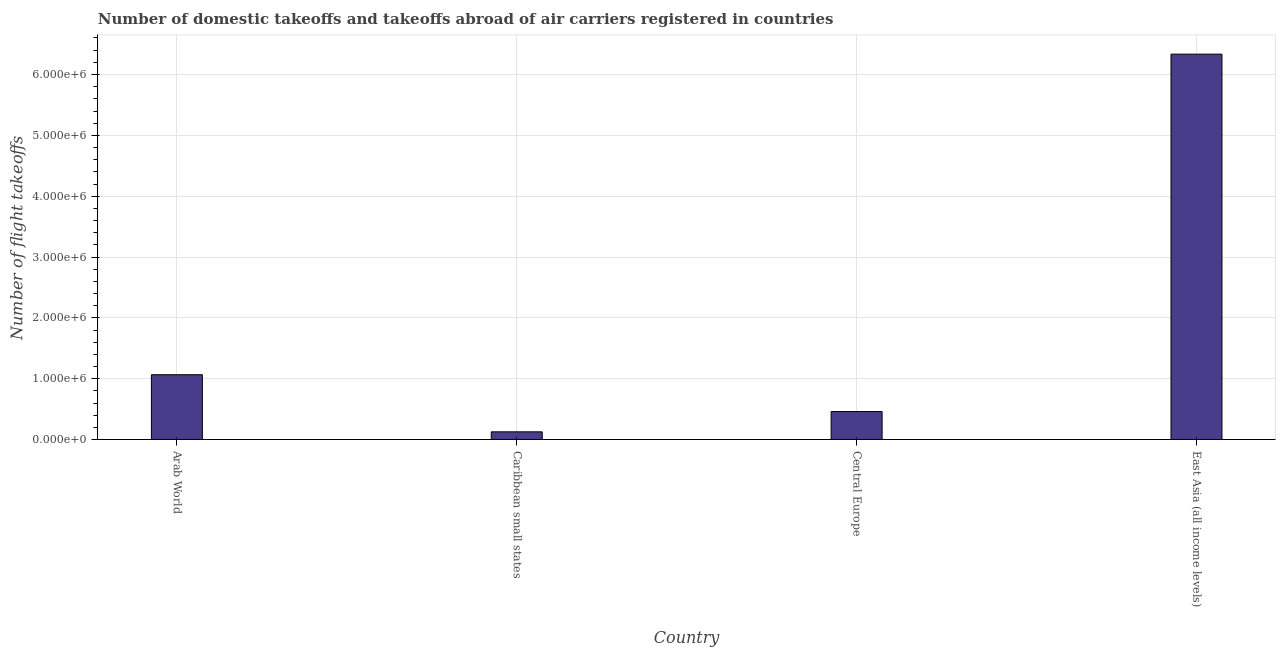What is the title of the graph?
Offer a very short reply. Number of domestic takeoffs and takeoffs abroad of air carriers registered in countries. What is the label or title of the X-axis?
Provide a short and direct response. Country. What is the label or title of the Y-axis?
Provide a succinct answer. Number of flight takeoffs. What is the number of flight takeoffs in Central Europe?
Offer a terse response. 4.60e+05. Across all countries, what is the maximum number of flight takeoffs?
Your response must be concise. 6.33e+06. Across all countries, what is the minimum number of flight takeoffs?
Your response must be concise. 1.26e+05. In which country was the number of flight takeoffs maximum?
Your answer should be very brief. East Asia (all income levels). In which country was the number of flight takeoffs minimum?
Your answer should be compact. Caribbean small states. What is the sum of the number of flight takeoffs?
Provide a succinct answer. 7.99e+06. What is the difference between the number of flight takeoffs in Caribbean small states and Central Europe?
Provide a short and direct response. -3.34e+05. What is the average number of flight takeoffs per country?
Offer a very short reply. 2.00e+06. What is the median number of flight takeoffs?
Offer a terse response. 7.63e+05. In how many countries, is the number of flight takeoffs greater than 5800000 ?
Your answer should be compact. 1. What is the ratio of the number of flight takeoffs in Arab World to that in East Asia (all income levels)?
Give a very brief answer. 0.17. What is the difference between the highest and the second highest number of flight takeoffs?
Make the answer very short. 5.27e+06. What is the difference between the highest and the lowest number of flight takeoffs?
Provide a short and direct response. 6.21e+06. In how many countries, is the number of flight takeoffs greater than the average number of flight takeoffs taken over all countries?
Offer a very short reply. 1. Are all the bars in the graph horizontal?
Your answer should be compact. No. What is the difference between two consecutive major ticks on the Y-axis?
Keep it short and to the point. 1.00e+06. Are the values on the major ticks of Y-axis written in scientific E-notation?
Your response must be concise. Yes. What is the Number of flight takeoffs in Arab World?
Your answer should be very brief. 1.07e+06. What is the Number of flight takeoffs in Caribbean small states?
Offer a terse response. 1.26e+05. What is the Number of flight takeoffs in Central Europe?
Offer a terse response. 4.60e+05. What is the Number of flight takeoffs in East Asia (all income levels)?
Offer a very short reply. 6.33e+06. What is the difference between the Number of flight takeoffs in Arab World and Caribbean small states?
Provide a short and direct response. 9.39e+05. What is the difference between the Number of flight takeoffs in Arab World and Central Europe?
Ensure brevity in your answer.  6.05e+05. What is the difference between the Number of flight takeoffs in Arab World and East Asia (all income levels)?
Give a very brief answer. -5.27e+06. What is the difference between the Number of flight takeoffs in Caribbean small states and Central Europe?
Your answer should be very brief. -3.34e+05. What is the difference between the Number of flight takeoffs in Caribbean small states and East Asia (all income levels)?
Provide a succinct answer. -6.21e+06. What is the difference between the Number of flight takeoffs in Central Europe and East Asia (all income levels)?
Your response must be concise. -5.87e+06. What is the ratio of the Number of flight takeoffs in Arab World to that in Caribbean small states?
Your answer should be compact. 8.43. What is the ratio of the Number of flight takeoffs in Arab World to that in Central Europe?
Ensure brevity in your answer.  2.31. What is the ratio of the Number of flight takeoffs in Arab World to that in East Asia (all income levels)?
Provide a succinct answer. 0.17. What is the ratio of the Number of flight takeoffs in Caribbean small states to that in Central Europe?
Give a very brief answer. 0.28. What is the ratio of the Number of flight takeoffs in Caribbean small states to that in East Asia (all income levels)?
Provide a succinct answer. 0.02. What is the ratio of the Number of flight takeoffs in Central Europe to that in East Asia (all income levels)?
Offer a terse response. 0.07. 